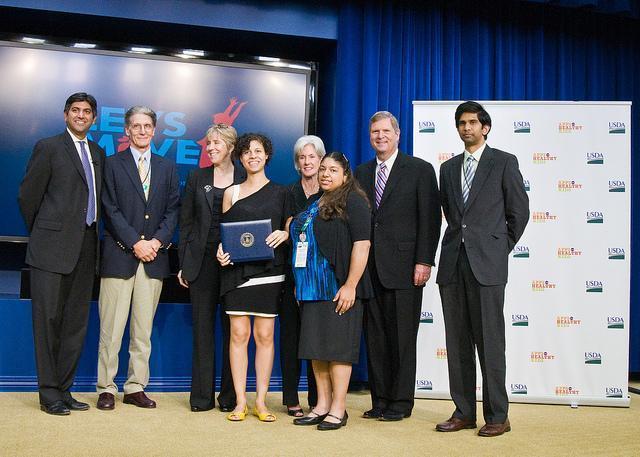How many women are in the pic?
Give a very brief answer. 4. How many people have yellow shoes?
Give a very brief answer. 1. How many people are in the picture?
Give a very brief answer. 8. How many doors on the bus are closed?
Give a very brief answer. 0. 